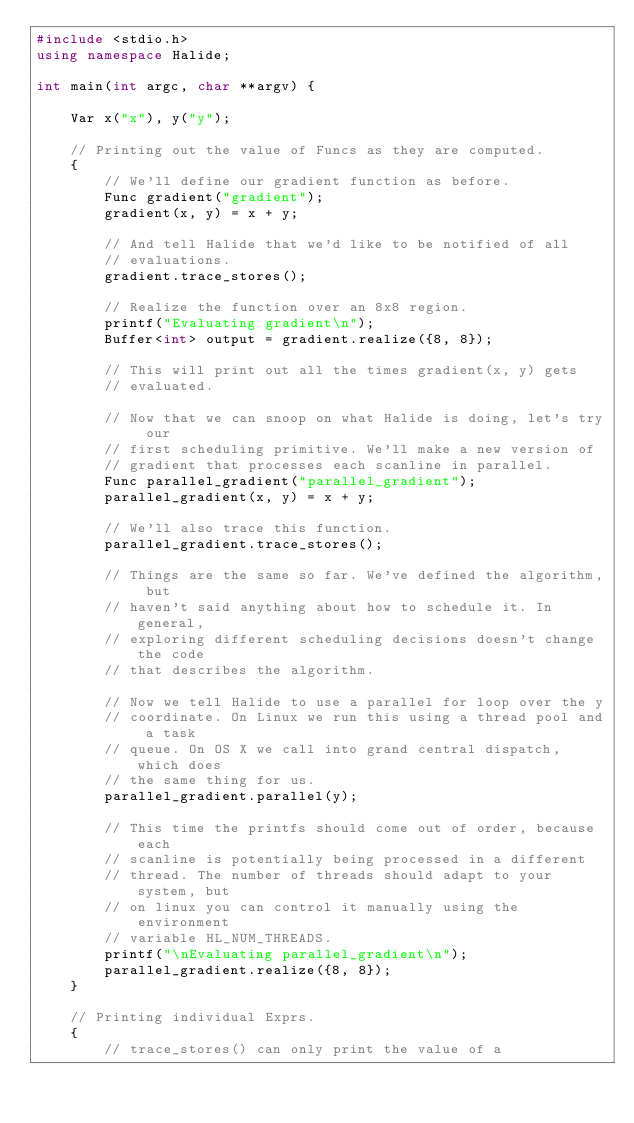<code> <loc_0><loc_0><loc_500><loc_500><_C++_>#include <stdio.h>
using namespace Halide;

int main(int argc, char **argv) {

    Var x("x"), y("y");

    // Printing out the value of Funcs as they are computed.
    {
        // We'll define our gradient function as before.
        Func gradient("gradient");
        gradient(x, y) = x + y;

        // And tell Halide that we'd like to be notified of all
        // evaluations.
        gradient.trace_stores();

        // Realize the function over an 8x8 region.
        printf("Evaluating gradient\n");
        Buffer<int> output = gradient.realize({8, 8});

        // This will print out all the times gradient(x, y) gets
        // evaluated.

        // Now that we can snoop on what Halide is doing, let's try our
        // first scheduling primitive. We'll make a new version of
        // gradient that processes each scanline in parallel.
        Func parallel_gradient("parallel_gradient");
        parallel_gradient(x, y) = x + y;

        // We'll also trace this function.
        parallel_gradient.trace_stores();

        // Things are the same so far. We've defined the algorithm, but
        // haven't said anything about how to schedule it. In general,
        // exploring different scheduling decisions doesn't change the code
        // that describes the algorithm.

        // Now we tell Halide to use a parallel for loop over the y
        // coordinate. On Linux we run this using a thread pool and a task
        // queue. On OS X we call into grand central dispatch, which does
        // the same thing for us.
        parallel_gradient.parallel(y);

        // This time the printfs should come out of order, because each
        // scanline is potentially being processed in a different
        // thread. The number of threads should adapt to your system, but
        // on linux you can control it manually using the environment
        // variable HL_NUM_THREADS.
        printf("\nEvaluating parallel_gradient\n");
        parallel_gradient.realize({8, 8});
    }

    // Printing individual Exprs.
    {
        // trace_stores() can only print the value of a</code> 